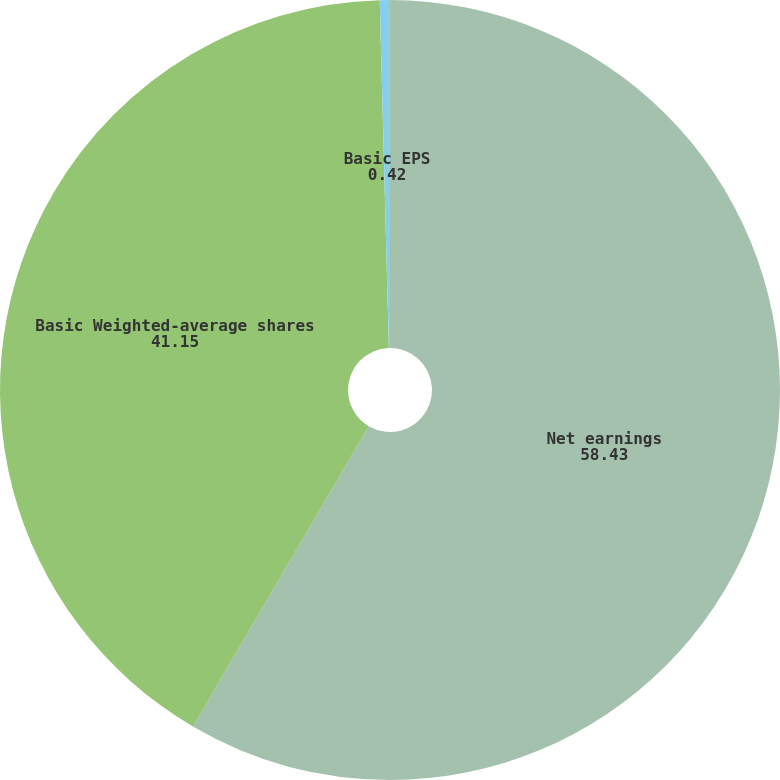Convert chart to OTSL. <chart><loc_0><loc_0><loc_500><loc_500><pie_chart><fcel>Net earnings<fcel>Basic Weighted-average shares<fcel>Basic EPS<nl><fcel>58.43%<fcel>41.15%<fcel>0.42%<nl></chart> 